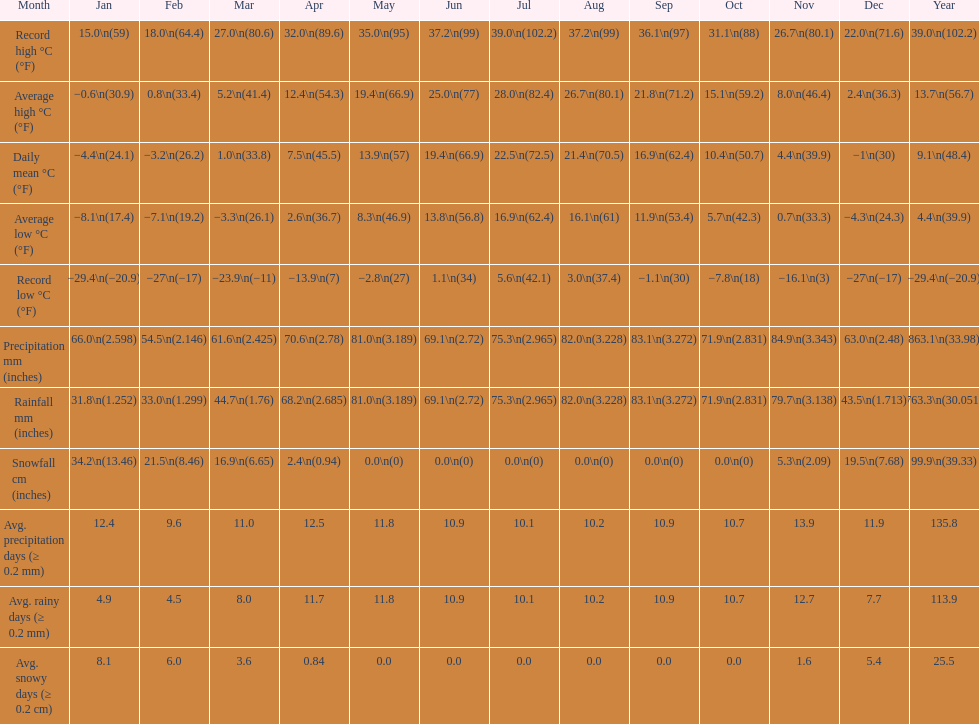Would you mind parsing the complete table? {'header': ['Month', 'Jan', 'Feb', 'Mar', 'Apr', 'May', 'Jun', 'Jul', 'Aug', 'Sep', 'Oct', 'Nov', 'Dec', 'Year'], 'rows': [['Record high °C (°F)', '15.0\\n(59)', '18.0\\n(64.4)', '27.0\\n(80.6)', '32.0\\n(89.6)', '35.0\\n(95)', '37.2\\n(99)', '39.0\\n(102.2)', '37.2\\n(99)', '36.1\\n(97)', '31.1\\n(88)', '26.7\\n(80.1)', '22.0\\n(71.6)', '39.0\\n(102.2)'], ['Average high °C (°F)', '−0.6\\n(30.9)', '0.8\\n(33.4)', '5.2\\n(41.4)', '12.4\\n(54.3)', '19.4\\n(66.9)', '25.0\\n(77)', '28.0\\n(82.4)', '26.7\\n(80.1)', '21.8\\n(71.2)', '15.1\\n(59.2)', '8.0\\n(46.4)', '2.4\\n(36.3)', '13.7\\n(56.7)'], ['Daily mean °C (°F)', '−4.4\\n(24.1)', '−3.2\\n(26.2)', '1.0\\n(33.8)', '7.5\\n(45.5)', '13.9\\n(57)', '19.4\\n(66.9)', '22.5\\n(72.5)', '21.4\\n(70.5)', '16.9\\n(62.4)', '10.4\\n(50.7)', '4.4\\n(39.9)', '−1\\n(30)', '9.1\\n(48.4)'], ['Average low °C (°F)', '−8.1\\n(17.4)', '−7.1\\n(19.2)', '−3.3\\n(26.1)', '2.6\\n(36.7)', '8.3\\n(46.9)', '13.8\\n(56.8)', '16.9\\n(62.4)', '16.1\\n(61)', '11.9\\n(53.4)', '5.7\\n(42.3)', '0.7\\n(33.3)', '−4.3\\n(24.3)', '4.4\\n(39.9)'], ['Record low °C (°F)', '−29.4\\n(−20.9)', '−27\\n(−17)', '−23.9\\n(−11)', '−13.9\\n(7)', '−2.8\\n(27)', '1.1\\n(34)', '5.6\\n(42.1)', '3.0\\n(37.4)', '−1.1\\n(30)', '−7.8\\n(18)', '−16.1\\n(3)', '−27\\n(−17)', '−29.4\\n(−20.9)'], ['Precipitation mm (inches)', '66.0\\n(2.598)', '54.5\\n(2.146)', '61.6\\n(2.425)', '70.6\\n(2.78)', '81.0\\n(3.189)', '69.1\\n(2.72)', '75.3\\n(2.965)', '82.0\\n(3.228)', '83.1\\n(3.272)', '71.9\\n(2.831)', '84.9\\n(3.343)', '63.0\\n(2.48)', '863.1\\n(33.98)'], ['Rainfall mm (inches)', '31.8\\n(1.252)', '33.0\\n(1.299)', '44.7\\n(1.76)', '68.2\\n(2.685)', '81.0\\n(3.189)', '69.1\\n(2.72)', '75.3\\n(2.965)', '82.0\\n(3.228)', '83.1\\n(3.272)', '71.9\\n(2.831)', '79.7\\n(3.138)', '43.5\\n(1.713)', '763.3\\n(30.051)'], ['Snowfall cm (inches)', '34.2\\n(13.46)', '21.5\\n(8.46)', '16.9\\n(6.65)', '2.4\\n(0.94)', '0.0\\n(0)', '0.0\\n(0)', '0.0\\n(0)', '0.0\\n(0)', '0.0\\n(0)', '0.0\\n(0)', '5.3\\n(2.09)', '19.5\\n(7.68)', '99.9\\n(39.33)'], ['Avg. precipitation days (≥ 0.2 mm)', '12.4', '9.6', '11.0', '12.5', '11.8', '10.9', '10.1', '10.2', '10.9', '10.7', '13.9', '11.9', '135.8'], ['Avg. rainy days (≥ 0.2 mm)', '4.9', '4.5', '8.0', '11.7', '11.8', '10.9', '10.1', '10.2', '10.9', '10.7', '12.7', '7.7', '113.9'], ['Avg. snowy days (≥ 0.2 cm)', '8.1', '6.0', '3.6', '0.84', '0.0', '0.0', '0.0', '0.0', '0.0', '0.0', '1.6', '5.4', '25.5']]} In how many months was the record high temperature above 1 11. 